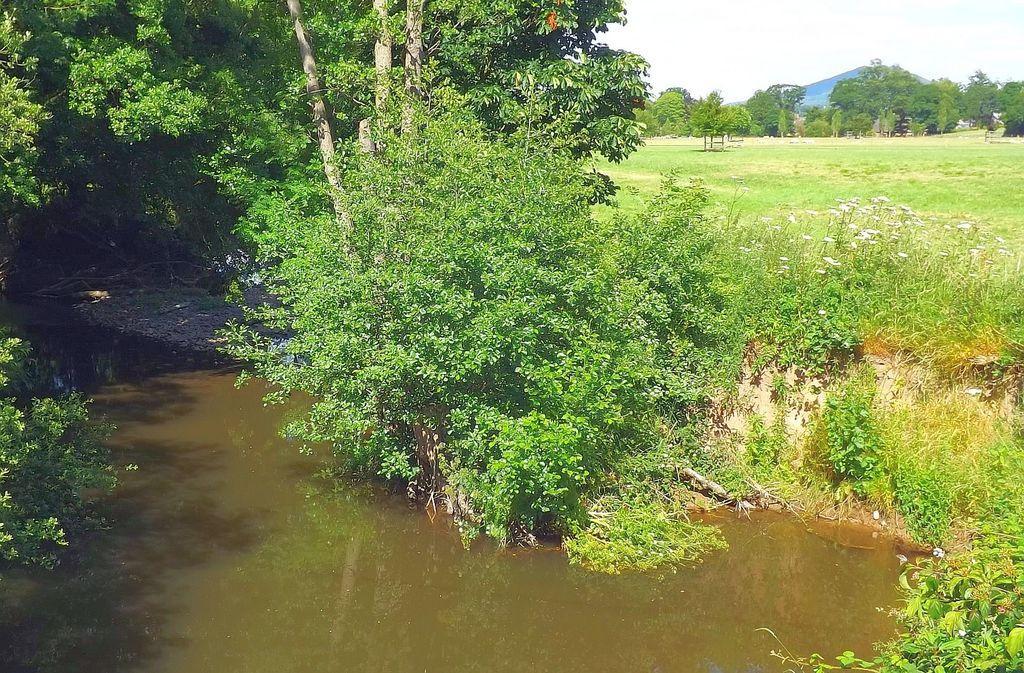How would you summarize this image in a sentence or two? In the foreground of this image, there is a river and trees beside it. In the background, there is grass, flowers, and, trees, a mountain and the sky. 